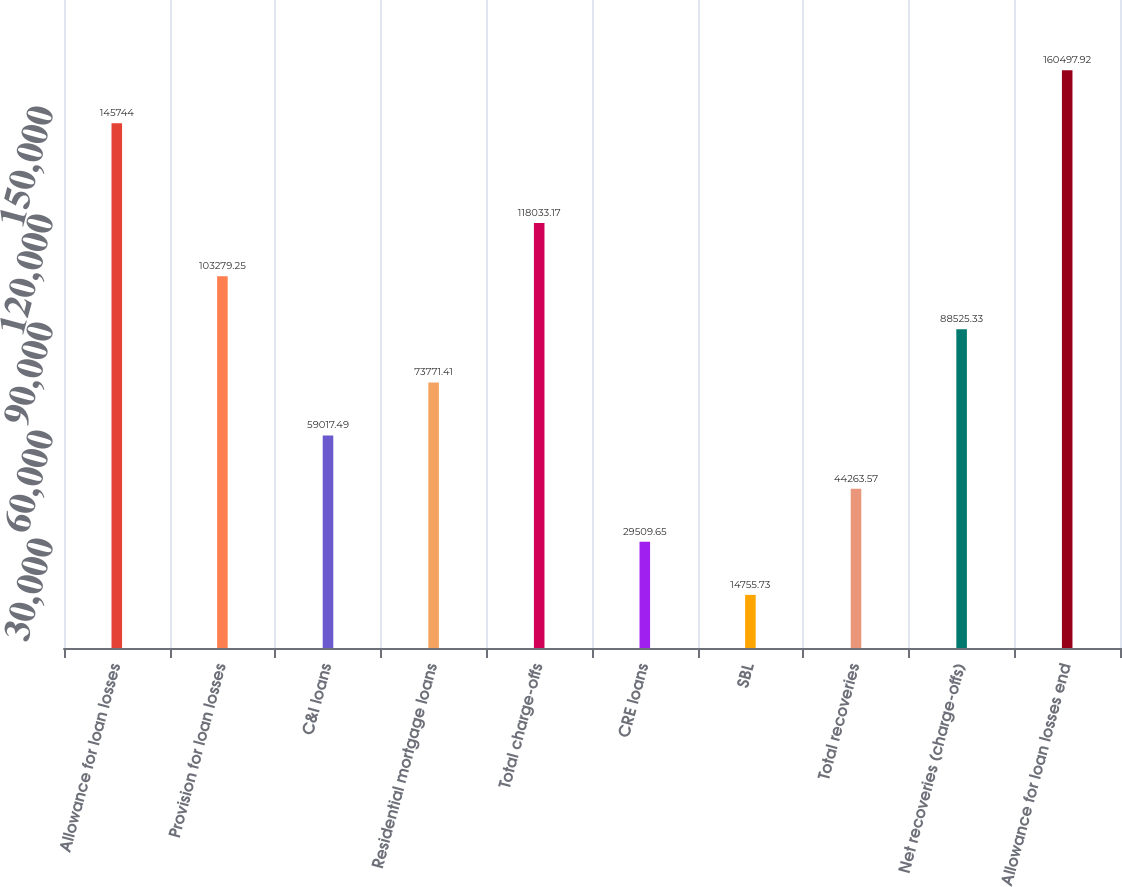Convert chart to OTSL. <chart><loc_0><loc_0><loc_500><loc_500><bar_chart><fcel>Allowance for loan losses<fcel>Provision for loan losses<fcel>C&I loans<fcel>Residential mortgage loans<fcel>Total charge-offs<fcel>CRE loans<fcel>SBL<fcel>Total recoveries<fcel>Net recoveries (charge-offs)<fcel>Allowance for loan losses end<nl><fcel>145744<fcel>103279<fcel>59017.5<fcel>73771.4<fcel>118033<fcel>29509.7<fcel>14755.7<fcel>44263.6<fcel>88525.3<fcel>160498<nl></chart> 